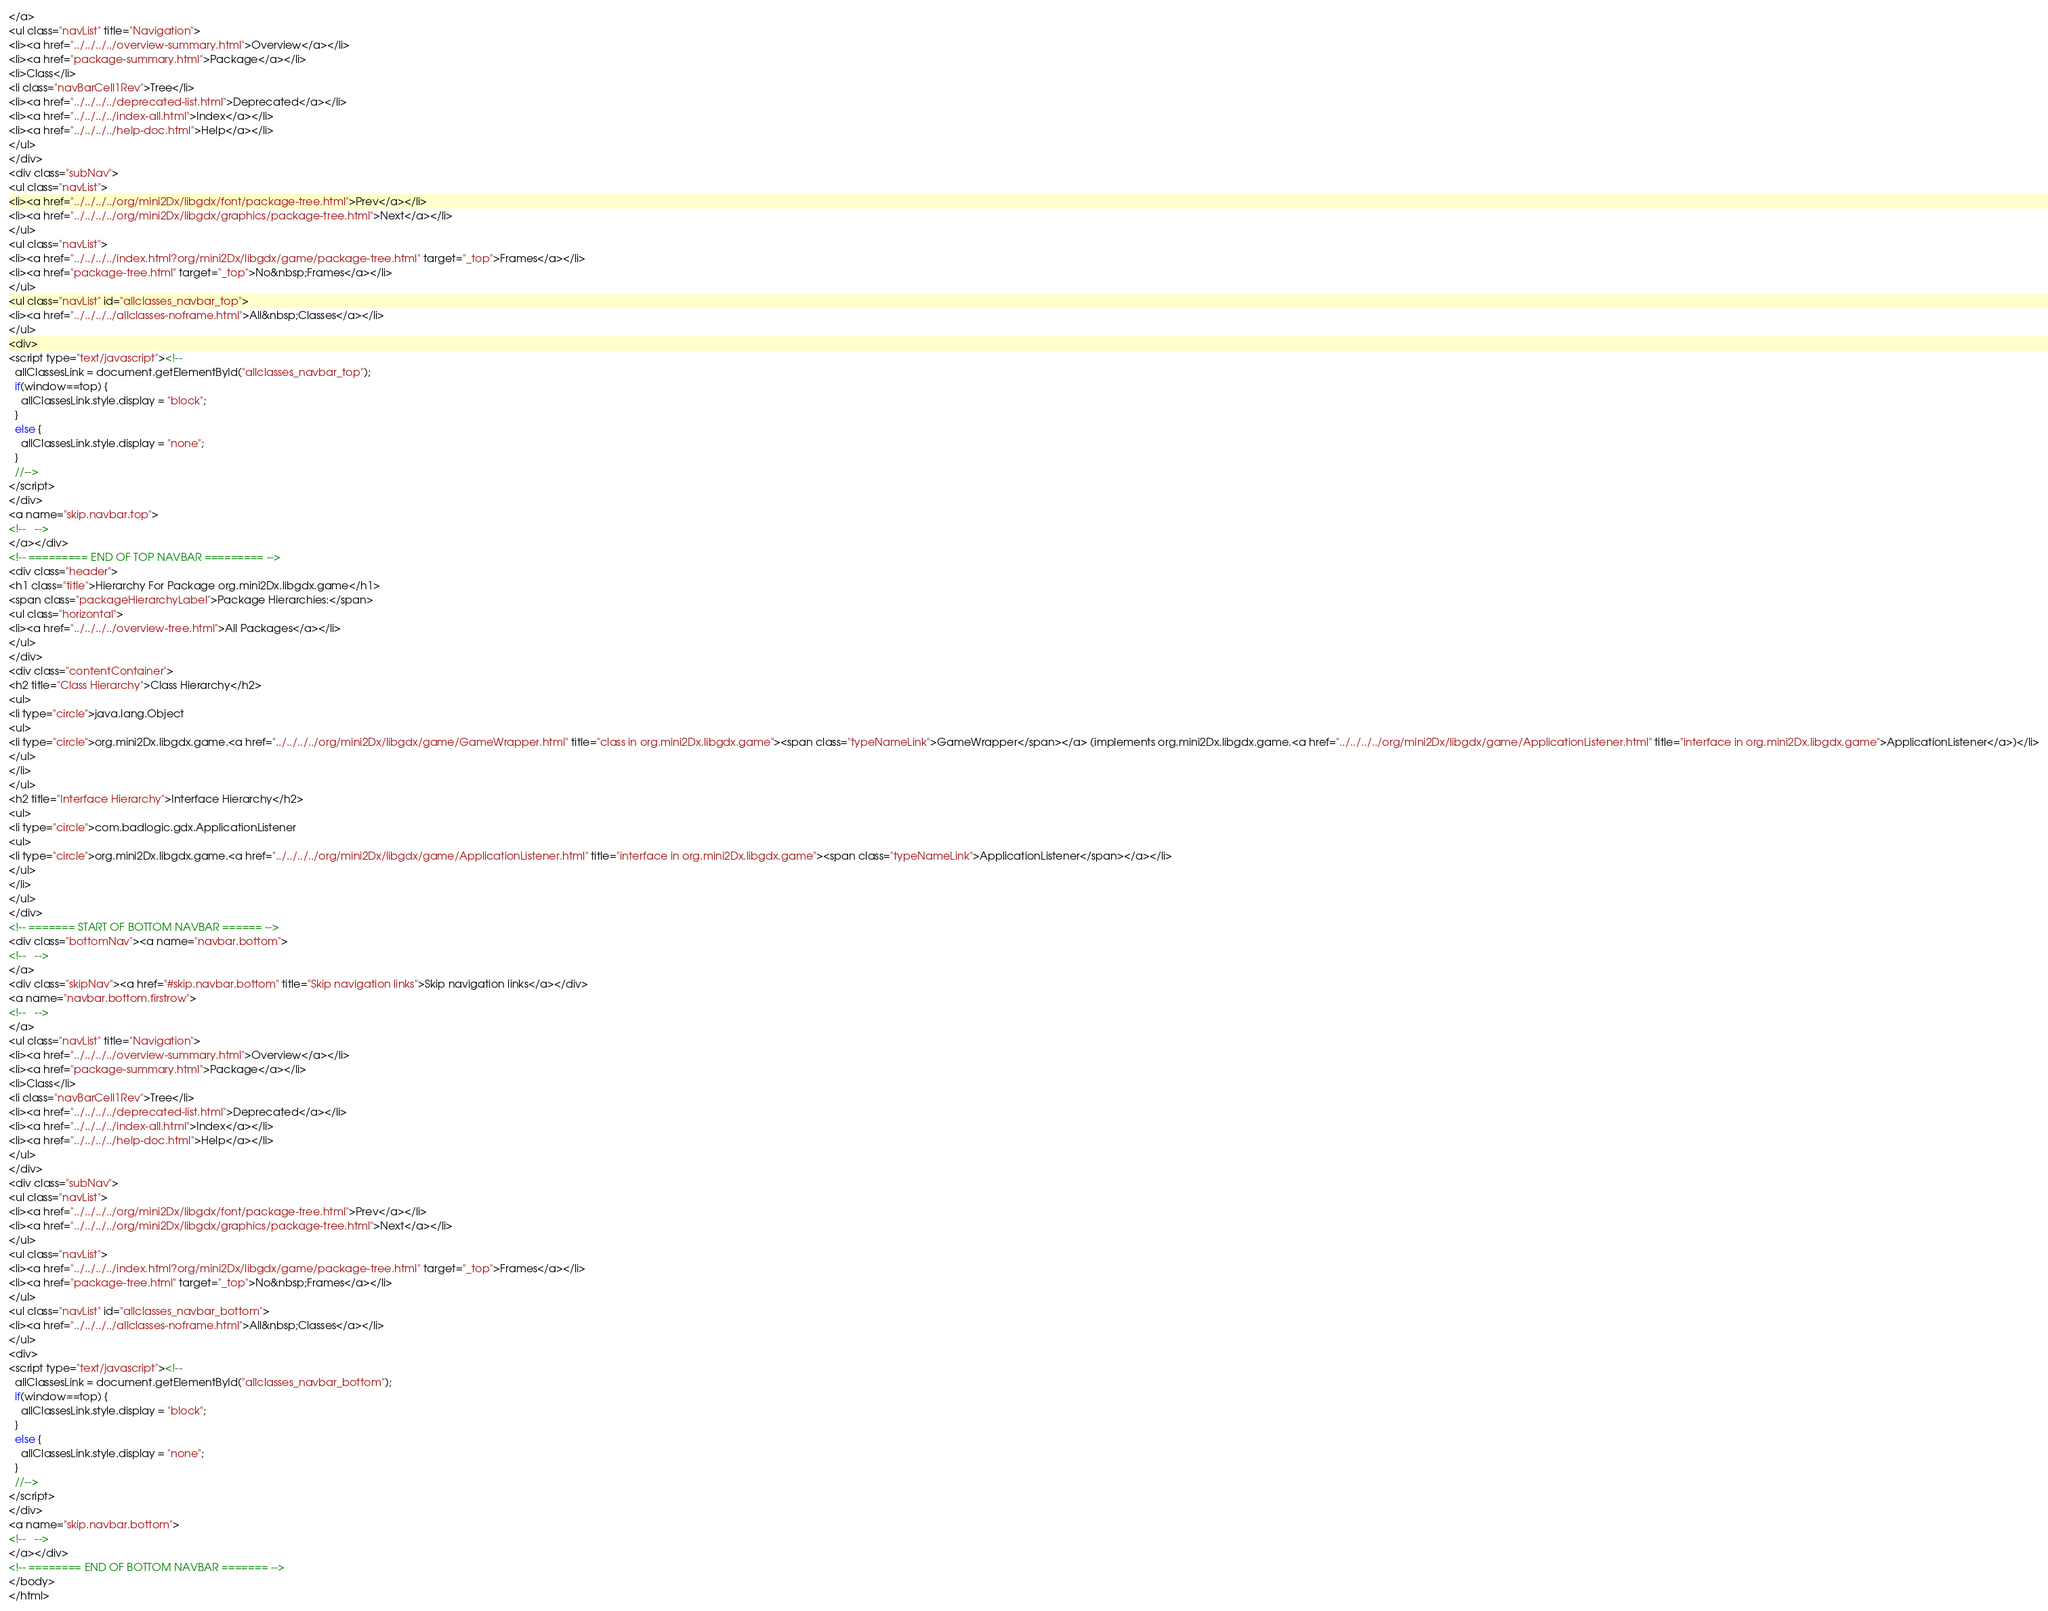Convert code to text. <code><loc_0><loc_0><loc_500><loc_500><_HTML_></a>
<ul class="navList" title="Navigation">
<li><a href="../../../../overview-summary.html">Overview</a></li>
<li><a href="package-summary.html">Package</a></li>
<li>Class</li>
<li class="navBarCell1Rev">Tree</li>
<li><a href="../../../../deprecated-list.html">Deprecated</a></li>
<li><a href="../../../../index-all.html">Index</a></li>
<li><a href="../../../../help-doc.html">Help</a></li>
</ul>
</div>
<div class="subNav">
<ul class="navList">
<li><a href="../../../../org/mini2Dx/libgdx/font/package-tree.html">Prev</a></li>
<li><a href="../../../../org/mini2Dx/libgdx/graphics/package-tree.html">Next</a></li>
</ul>
<ul class="navList">
<li><a href="../../../../index.html?org/mini2Dx/libgdx/game/package-tree.html" target="_top">Frames</a></li>
<li><a href="package-tree.html" target="_top">No&nbsp;Frames</a></li>
</ul>
<ul class="navList" id="allclasses_navbar_top">
<li><a href="../../../../allclasses-noframe.html">All&nbsp;Classes</a></li>
</ul>
<div>
<script type="text/javascript"><!--
  allClassesLink = document.getElementById("allclasses_navbar_top");
  if(window==top) {
    allClassesLink.style.display = "block";
  }
  else {
    allClassesLink.style.display = "none";
  }
  //-->
</script>
</div>
<a name="skip.navbar.top">
<!--   -->
</a></div>
<!-- ========= END OF TOP NAVBAR ========= -->
<div class="header">
<h1 class="title">Hierarchy For Package org.mini2Dx.libgdx.game</h1>
<span class="packageHierarchyLabel">Package Hierarchies:</span>
<ul class="horizontal">
<li><a href="../../../../overview-tree.html">All Packages</a></li>
</ul>
</div>
<div class="contentContainer">
<h2 title="Class Hierarchy">Class Hierarchy</h2>
<ul>
<li type="circle">java.lang.Object
<ul>
<li type="circle">org.mini2Dx.libgdx.game.<a href="../../../../org/mini2Dx/libgdx/game/GameWrapper.html" title="class in org.mini2Dx.libgdx.game"><span class="typeNameLink">GameWrapper</span></a> (implements org.mini2Dx.libgdx.game.<a href="../../../../org/mini2Dx/libgdx/game/ApplicationListener.html" title="interface in org.mini2Dx.libgdx.game">ApplicationListener</a>)</li>
</ul>
</li>
</ul>
<h2 title="Interface Hierarchy">Interface Hierarchy</h2>
<ul>
<li type="circle">com.badlogic.gdx.ApplicationListener
<ul>
<li type="circle">org.mini2Dx.libgdx.game.<a href="../../../../org/mini2Dx/libgdx/game/ApplicationListener.html" title="interface in org.mini2Dx.libgdx.game"><span class="typeNameLink">ApplicationListener</span></a></li>
</ul>
</li>
</ul>
</div>
<!-- ======= START OF BOTTOM NAVBAR ====== -->
<div class="bottomNav"><a name="navbar.bottom">
<!--   -->
</a>
<div class="skipNav"><a href="#skip.navbar.bottom" title="Skip navigation links">Skip navigation links</a></div>
<a name="navbar.bottom.firstrow">
<!--   -->
</a>
<ul class="navList" title="Navigation">
<li><a href="../../../../overview-summary.html">Overview</a></li>
<li><a href="package-summary.html">Package</a></li>
<li>Class</li>
<li class="navBarCell1Rev">Tree</li>
<li><a href="../../../../deprecated-list.html">Deprecated</a></li>
<li><a href="../../../../index-all.html">Index</a></li>
<li><a href="../../../../help-doc.html">Help</a></li>
</ul>
</div>
<div class="subNav">
<ul class="navList">
<li><a href="../../../../org/mini2Dx/libgdx/font/package-tree.html">Prev</a></li>
<li><a href="../../../../org/mini2Dx/libgdx/graphics/package-tree.html">Next</a></li>
</ul>
<ul class="navList">
<li><a href="../../../../index.html?org/mini2Dx/libgdx/game/package-tree.html" target="_top">Frames</a></li>
<li><a href="package-tree.html" target="_top">No&nbsp;Frames</a></li>
</ul>
<ul class="navList" id="allclasses_navbar_bottom">
<li><a href="../../../../allclasses-noframe.html">All&nbsp;Classes</a></li>
</ul>
<div>
<script type="text/javascript"><!--
  allClassesLink = document.getElementById("allclasses_navbar_bottom");
  if(window==top) {
    allClassesLink.style.display = "block";
  }
  else {
    allClassesLink.style.display = "none";
  }
  //-->
</script>
</div>
<a name="skip.navbar.bottom">
<!--   -->
</a></div>
<!-- ======== END OF BOTTOM NAVBAR ======= -->
</body>
</html>
</code> 